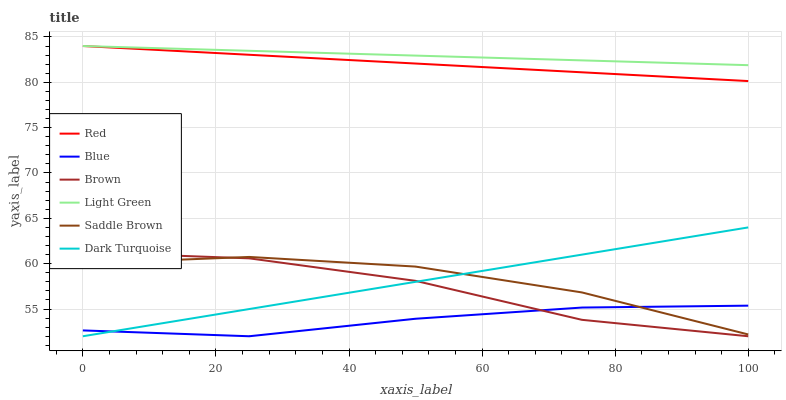Does Blue have the minimum area under the curve?
Answer yes or no. Yes. Does Light Green have the maximum area under the curve?
Answer yes or no. Yes. Does Brown have the minimum area under the curve?
Answer yes or no. No. Does Brown have the maximum area under the curve?
Answer yes or no. No. Is Dark Turquoise the smoothest?
Answer yes or no. Yes. Is Brown the roughest?
Answer yes or no. Yes. Is Brown the smoothest?
Answer yes or no. No. Is Dark Turquoise the roughest?
Answer yes or no. No. Does Blue have the lowest value?
Answer yes or no. Yes. Does Light Green have the lowest value?
Answer yes or no. No. Does Red have the highest value?
Answer yes or no. Yes. Does Brown have the highest value?
Answer yes or no. No. Is Dark Turquoise less than Light Green?
Answer yes or no. Yes. Is Light Green greater than Brown?
Answer yes or no. Yes. Does Saddle Brown intersect Dark Turquoise?
Answer yes or no. Yes. Is Saddle Brown less than Dark Turquoise?
Answer yes or no. No. Is Saddle Brown greater than Dark Turquoise?
Answer yes or no. No. Does Dark Turquoise intersect Light Green?
Answer yes or no. No. 